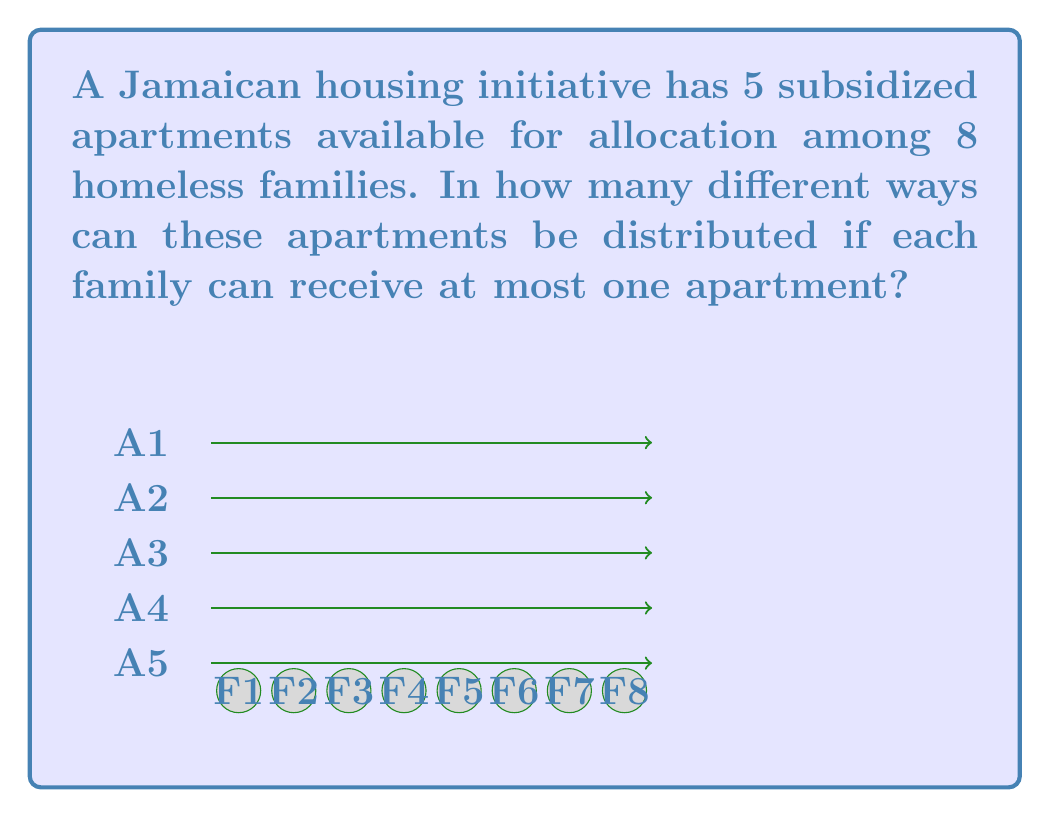Provide a solution to this math problem. To solve this problem, we can use the concept of combinations. We're selecting 5 families out of 8 to receive apartments, where the order doesn't matter (as we're not assigning specific apartments to specific families).

1) This scenario can be represented by the combination formula:

   $$C(n,r) = \binom{n}{r} = \frac{n!}{r!(n-r)!}$$

   Where $n$ is the total number of families and $r$ is the number of apartments.

2) In this case, $n = 8$ and $r = 5$. So we're calculating:

   $$C(8,5) = \binom{8}{5} = \frac{8!}{5!(8-5)!} = \frac{8!}{5!3!}$$

3) Let's expand this:
   
   $$\frac{8 \cdot 7 \cdot 6 \cdot 5!}{5! \cdot 3 \cdot 2 \cdot 1}$$

4) The $5!$ cancels out in the numerator and denominator:

   $$\frac{8 \cdot 7 \cdot 6}{3 \cdot 2 \cdot 1} = \frac{336}{6} = 56$$

Therefore, there are 56 different ways to distribute the 5 apartments among the 8 families.
Answer: 56 